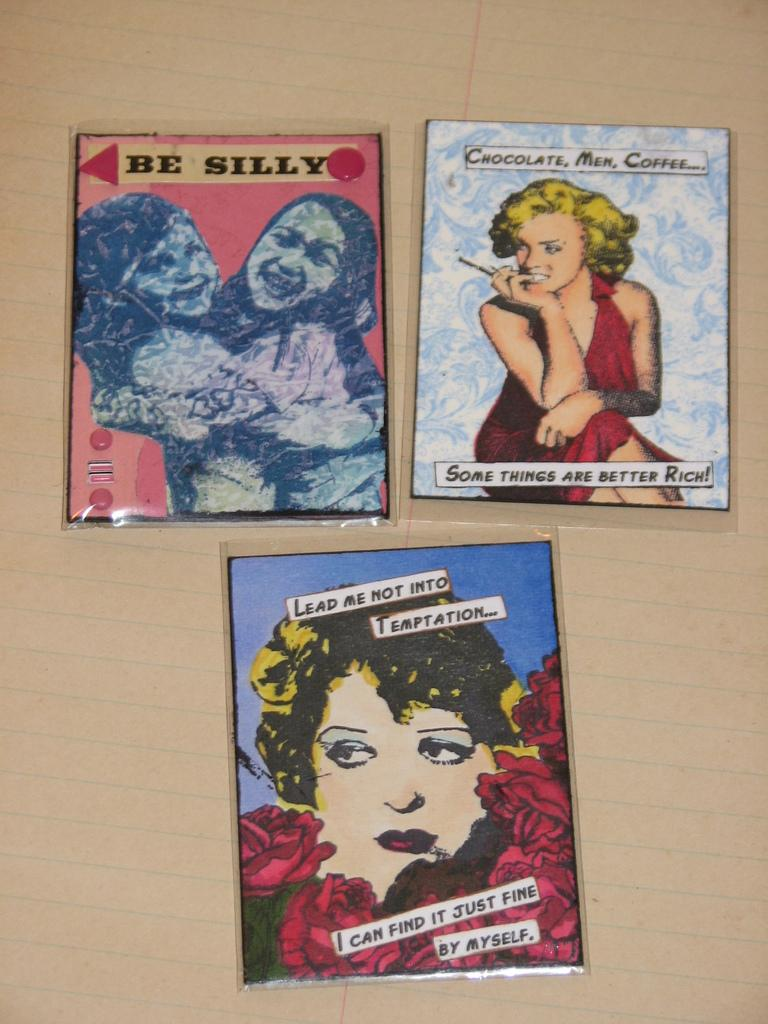What is present in the image that contains visual representations? There are pictures in the image. What is covering the paper in the image? Plastic covers are on the paper. What types of images can be seen in the pictures? The pictures contain images of people and flowers. Is there any text present on the pictures? Yes, there is writing on the pictures. How many snails can be seen crawling on the hydrant in the image? There is no hydrant or snails present in the image. 